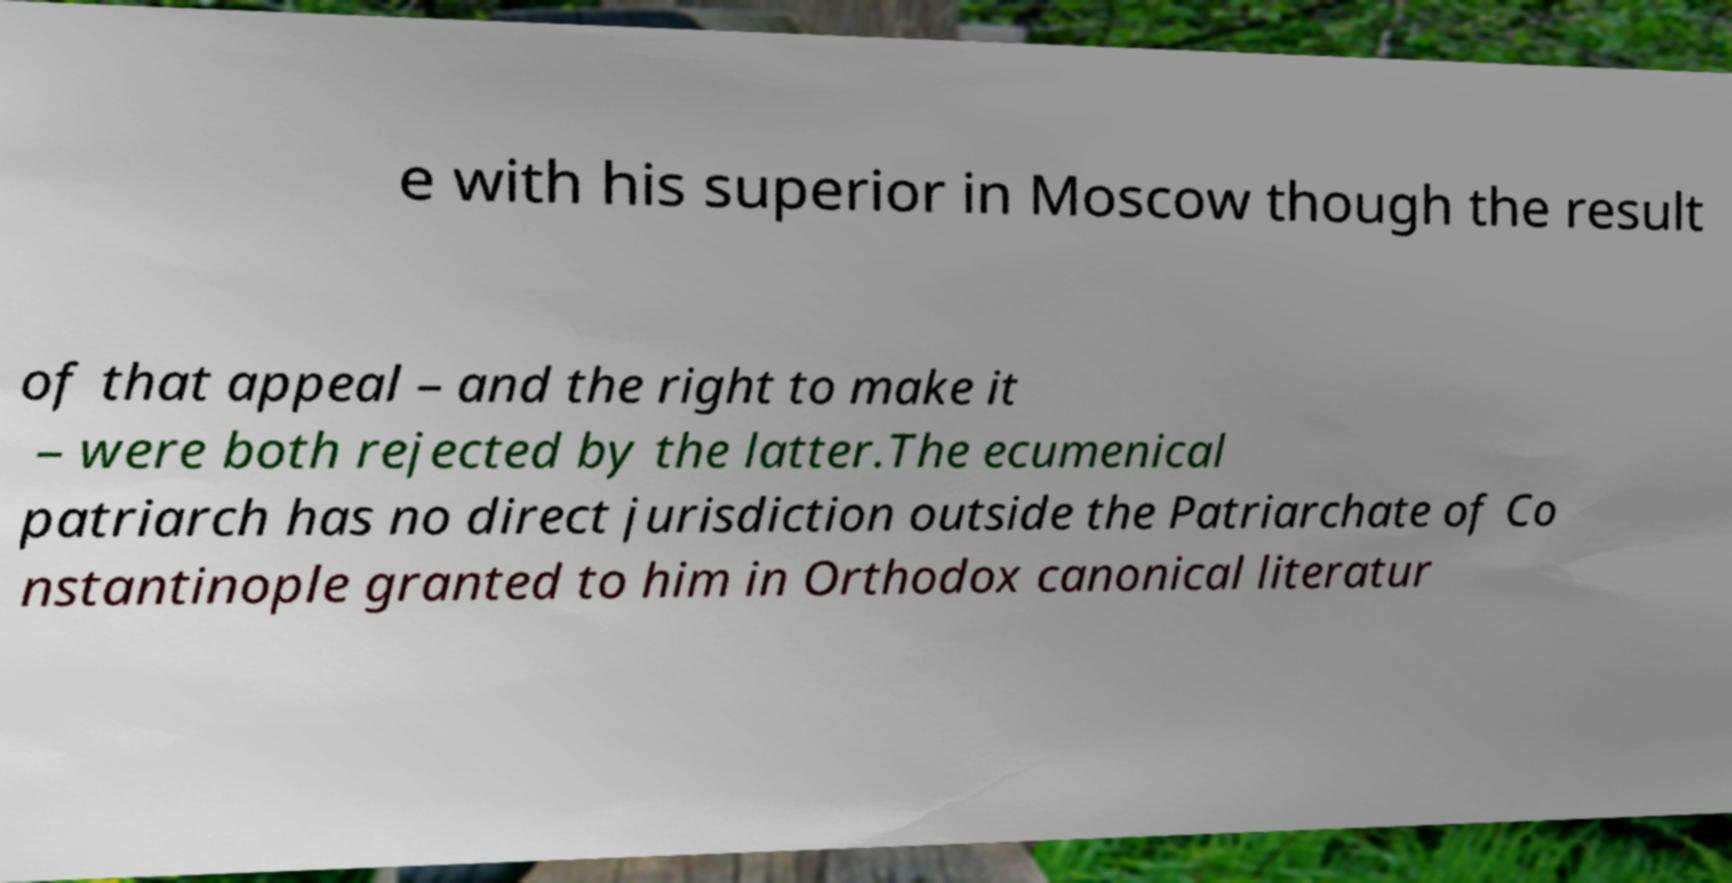I need the written content from this picture converted into text. Can you do that? e with his superior in Moscow though the result of that appeal – and the right to make it – were both rejected by the latter.The ecumenical patriarch has no direct jurisdiction outside the Patriarchate of Co nstantinople granted to him in Orthodox canonical literatur 